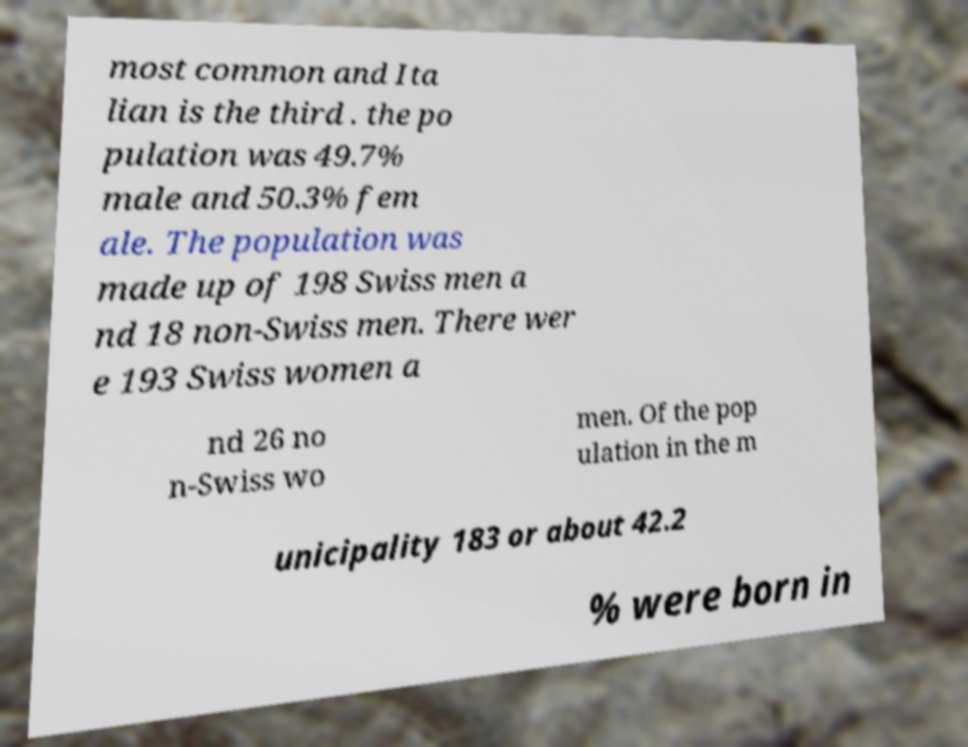What messages or text are displayed in this image? I need them in a readable, typed format. most common and Ita lian is the third . the po pulation was 49.7% male and 50.3% fem ale. The population was made up of 198 Swiss men a nd 18 non-Swiss men. There wer e 193 Swiss women a nd 26 no n-Swiss wo men. Of the pop ulation in the m unicipality 183 or about 42.2 % were born in 